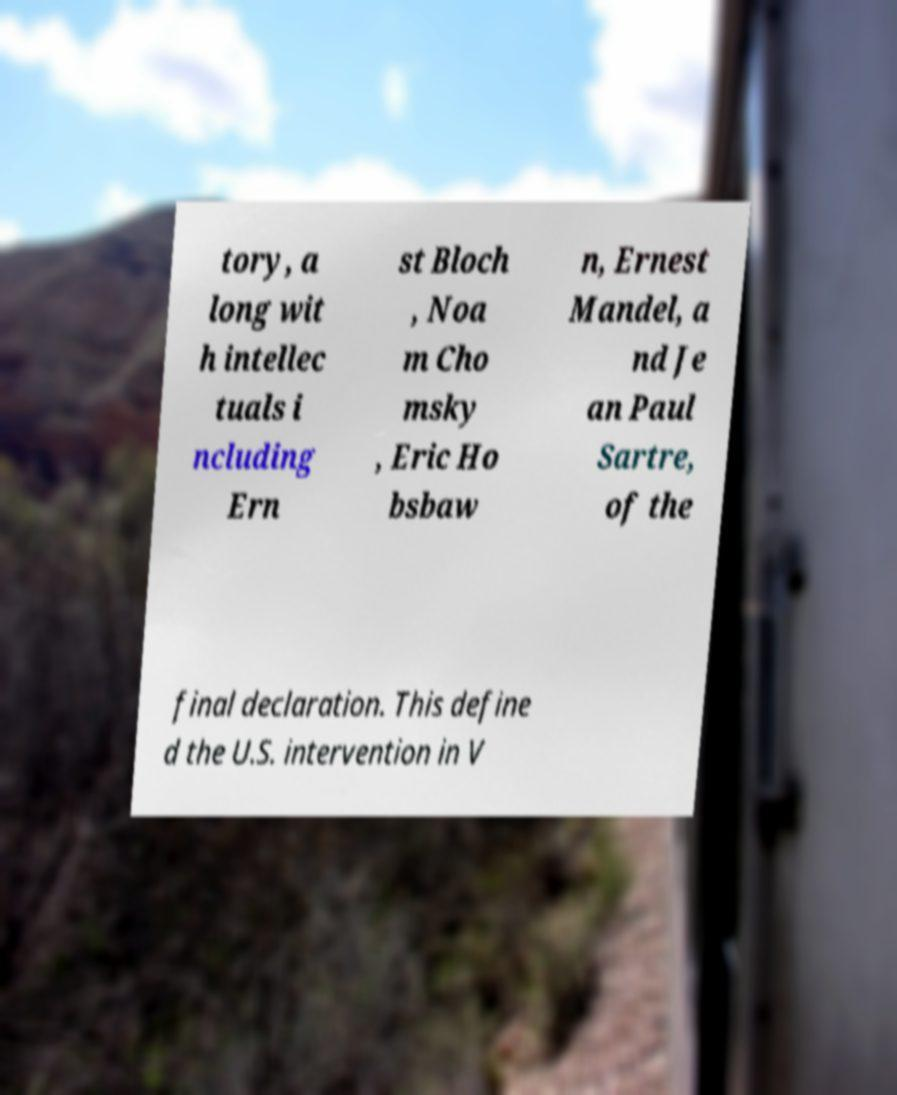Please identify and transcribe the text found in this image. tory, a long wit h intellec tuals i ncluding Ern st Bloch , Noa m Cho msky , Eric Ho bsbaw n, Ernest Mandel, a nd Je an Paul Sartre, of the final declaration. This define d the U.S. intervention in V 